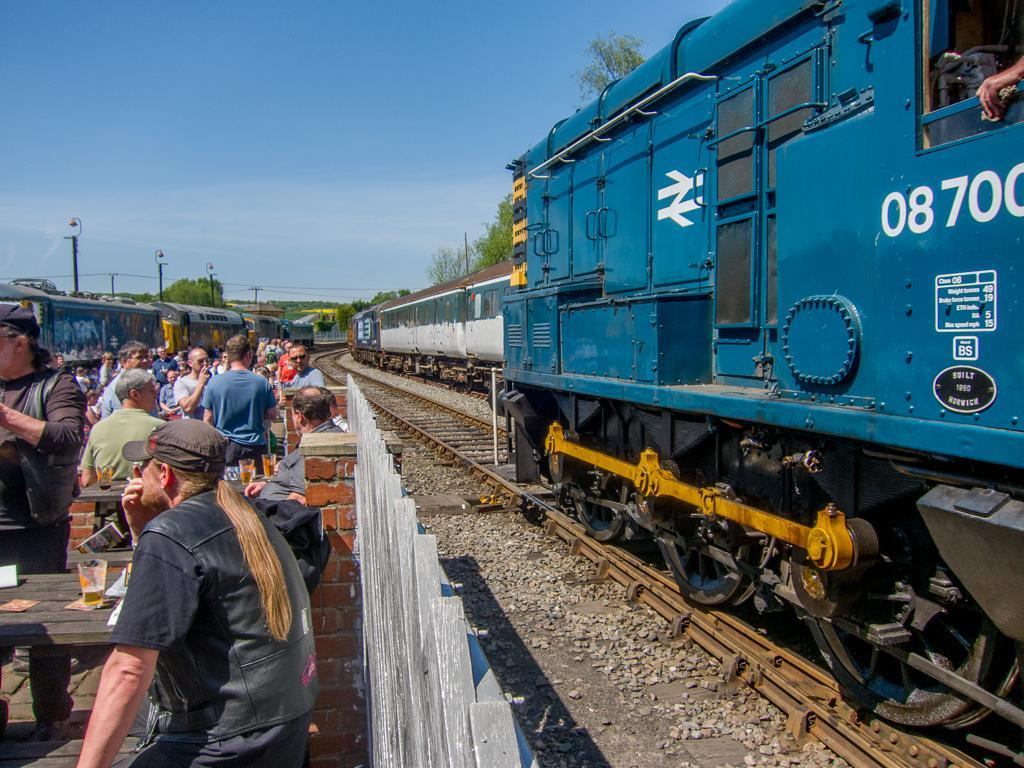<image>
Render a clear and concise summary of the photo. People standing in front of a blue train which says 08700 on it. 